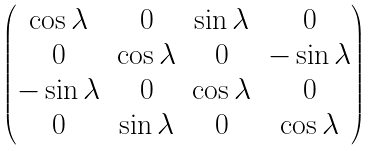Convert formula to latex. <formula><loc_0><loc_0><loc_500><loc_500>\begin{pmatrix} \cos \lambda & 0 & \sin \lambda & 0 \\ 0 & \cos \lambda & 0 & - \sin \lambda \\ - \sin \lambda & 0 & \cos \lambda & 0 \\ 0 & \sin \lambda & 0 & \cos \lambda \end{pmatrix}</formula> 